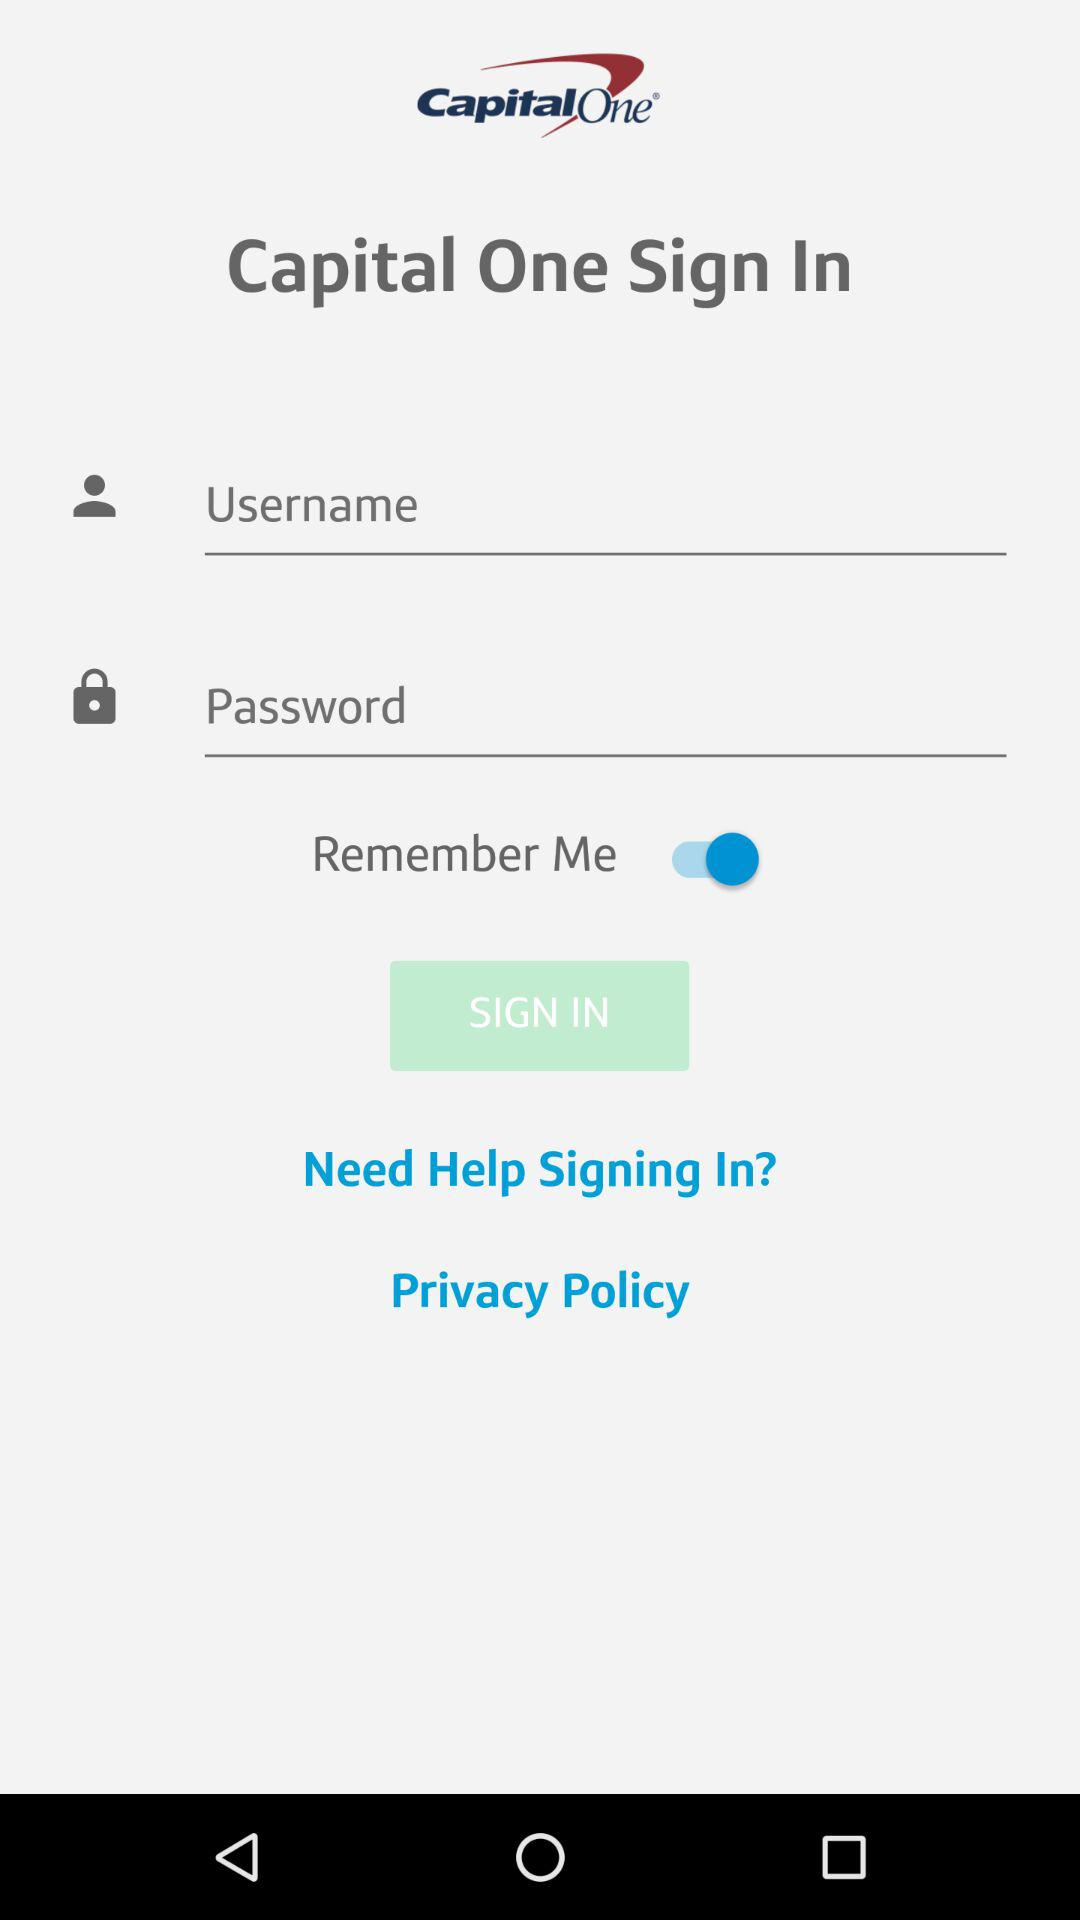What is the name of the company? The name of the company is "Capital One". 